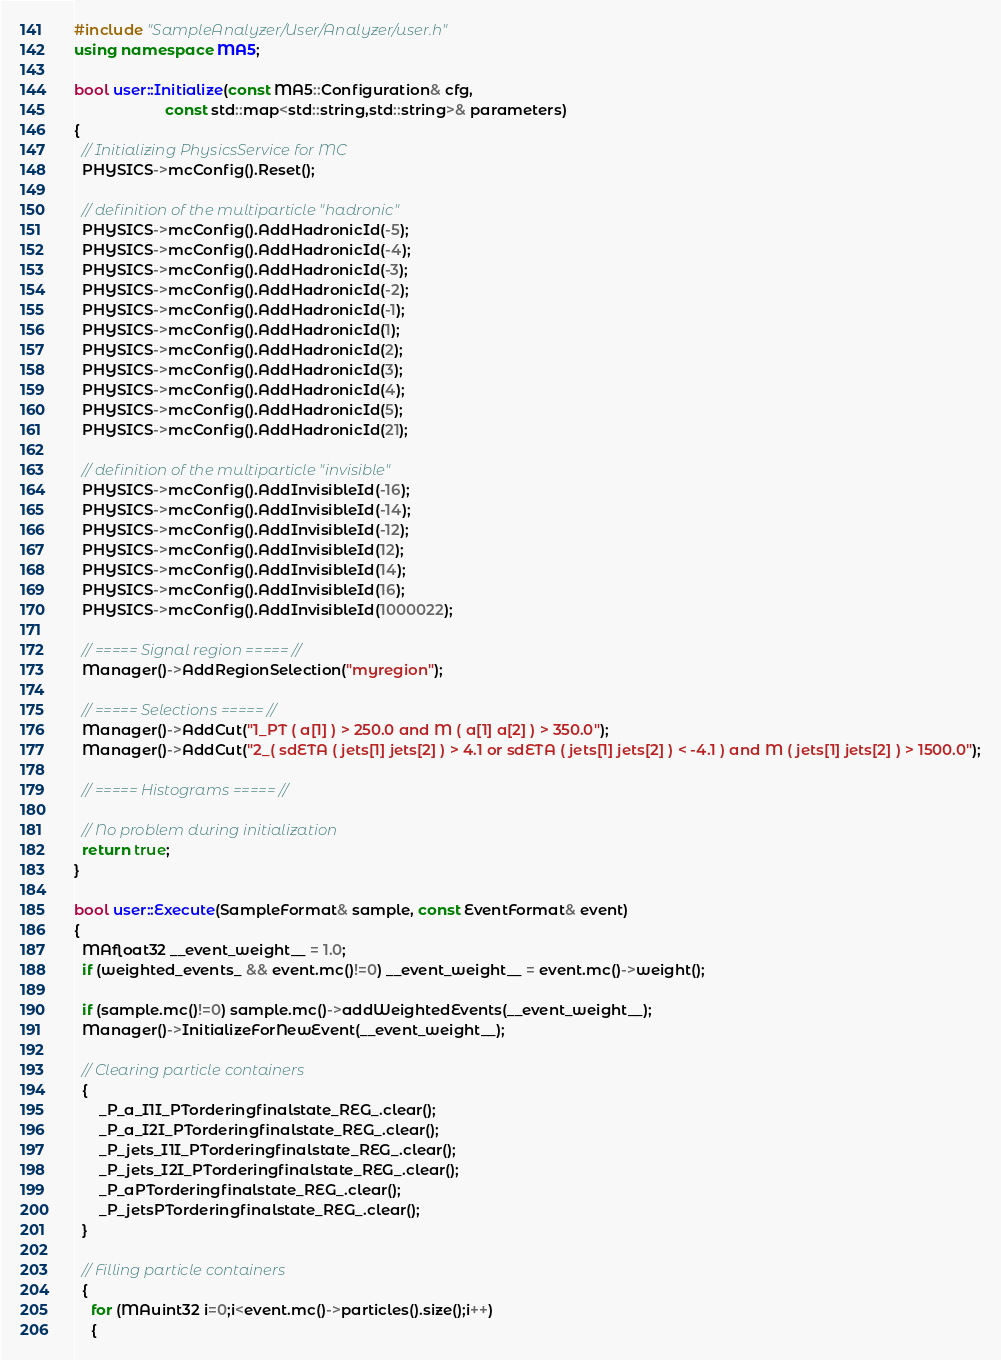<code> <loc_0><loc_0><loc_500><loc_500><_C++_>#include "SampleAnalyzer/User/Analyzer/user.h"
using namespace MA5;

bool user::Initialize(const MA5::Configuration& cfg,
                      const std::map<std::string,std::string>& parameters)
{
  // Initializing PhysicsService for MC
  PHYSICS->mcConfig().Reset();

  // definition of the multiparticle "hadronic"
  PHYSICS->mcConfig().AddHadronicId(-5);
  PHYSICS->mcConfig().AddHadronicId(-4);
  PHYSICS->mcConfig().AddHadronicId(-3);
  PHYSICS->mcConfig().AddHadronicId(-2);
  PHYSICS->mcConfig().AddHadronicId(-1);
  PHYSICS->mcConfig().AddHadronicId(1);
  PHYSICS->mcConfig().AddHadronicId(2);
  PHYSICS->mcConfig().AddHadronicId(3);
  PHYSICS->mcConfig().AddHadronicId(4);
  PHYSICS->mcConfig().AddHadronicId(5);
  PHYSICS->mcConfig().AddHadronicId(21);

  // definition of the multiparticle "invisible"
  PHYSICS->mcConfig().AddInvisibleId(-16);
  PHYSICS->mcConfig().AddInvisibleId(-14);
  PHYSICS->mcConfig().AddInvisibleId(-12);
  PHYSICS->mcConfig().AddInvisibleId(12);
  PHYSICS->mcConfig().AddInvisibleId(14);
  PHYSICS->mcConfig().AddInvisibleId(16);
  PHYSICS->mcConfig().AddInvisibleId(1000022);

  // ===== Signal region ===== //
  Manager()->AddRegionSelection("myregion");

  // ===== Selections ===== //
  Manager()->AddCut("1_PT ( a[1] ) > 250.0 and M ( a[1] a[2] ) > 350.0");
  Manager()->AddCut("2_( sdETA ( jets[1] jets[2] ) > 4.1 or sdETA ( jets[1] jets[2] ) < -4.1 ) and M ( jets[1] jets[2] ) > 1500.0");

  // ===== Histograms ===== //

  // No problem during initialization
  return true;
}

bool user::Execute(SampleFormat& sample, const EventFormat& event)
{
  MAfloat32 __event_weight__ = 1.0;
  if (weighted_events_ && event.mc()!=0) __event_weight__ = event.mc()->weight();

  if (sample.mc()!=0) sample.mc()->addWeightedEvents(__event_weight__);
  Manager()->InitializeForNewEvent(__event_weight__);

  // Clearing particle containers
  {
      _P_a_I1I_PTorderingfinalstate_REG_.clear();
      _P_a_I2I_PTorderingfinalstate_REG_.clear();
      _P_jets_I1I_PTorderingfinalstate_REG_.clear();
      _P_jets_I2I_PTorderingfinalstate_REG_.clear();
      _P_aPTorderingfinalstate_REG_.clear();
      _P_jetsPTorderingfinalstate_REG_.clear();
  }

  // Filling particle containers
  {
    for (MAuint32 i=0;i<event.mc()->particles().size();i++)
    {</code> 